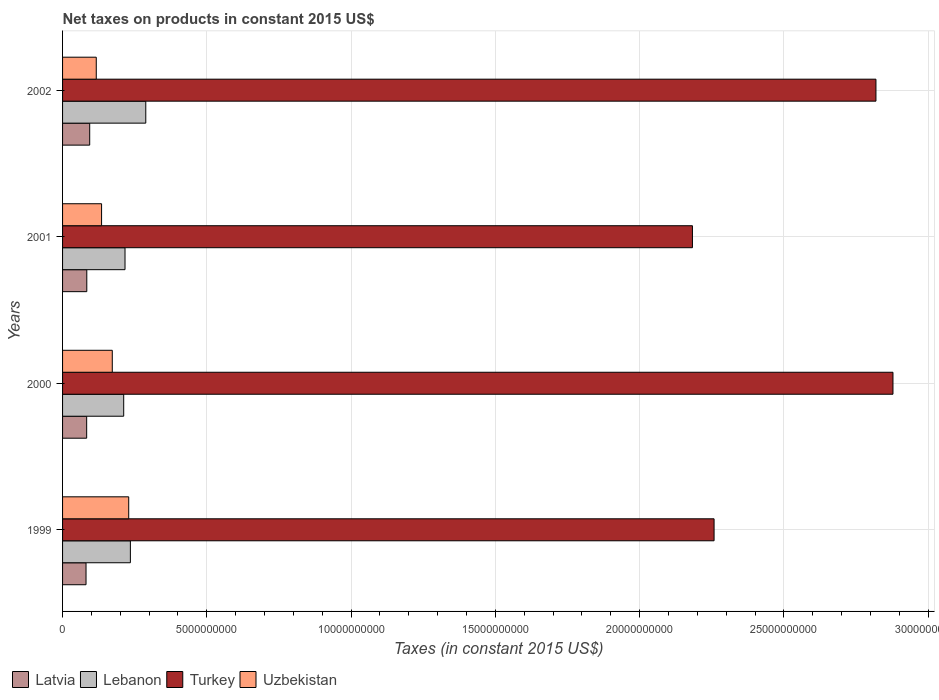How many different coloured bars are there?
Offer a very short reply. 4. How many groups of bars are there?
Offer a very short reply. 4. How many bars are there on the 2nd tick from the top?
Keep it short and to the point. 4. In how many cases, is the number of bars for a given year not equal to the number of legend labels?
Ensure brevity in your answer.  0. What is the net taxes on products in Latvia in 2000?
Provide a succinct answer. 8.36e+08. Across all years, what is the maximum net taxes on products in Lebanon?
Your answer should be compact. 2.88e+09. Across all years, what is the minimum net taxes on products in Turkey?
Your response must be concise. 2.18e+1. In which year was the net taxes on products in Uzbekistan maximum?
Ensure brevity in your answer.  1999. What is the total net taxes on products in Lebanon in the graph?
Your answer should be very brief. 9.52e+09. What is the difference between the net taxes on products in Turkey in 2000 and that in 2001?
Make the answer very short. 6.95e+09. What is the difference between the net taxes on products in Latvia in 2000 and the net taxes on products in Turkey in 1999?
Your answer should be compact. -2.17e+1. What is the average net taxes on products in Turkey per year?
Give a very brief answer. 2.53e+1. In the year 1999, what is the difference between the net taxes on products in Uzbekistan and net taxes on products in Turkey?
Keep it short and to the point. -2.03e+1. What is the ratio of the net taxes on products in Latvia in 1999 to that in 2002?
Keep it short and to the point. 0.86. Is the net taxes on products in Lebanon in 1999 less than that in 2001?
Keep it short and to the point. No. What is the difference between the highest and the second highest net taxes on products in Uzbekistan?
Provide a short and direct response. 5.70e+08. What is the difference between the highest and the lowest net taxes on products in Latvia?
Give a very brief answer. 1.27e+08. In how many years, is the net taxes on products in Uzbekistan greater than the average net taxes on products in Uzbekistan taken over all years?
Ensure brevity in your answer.  2. Is it the case that in every year, the sum of the net taxes on products in Uzbekistan and net taxes on products in Latvia is greater than the sum of net taxes on products in Lebanon and net taxes on products in Turkey?
Offer a terse response. No. What does the 4th bar from the top in 1999 represents?
Provide a short and direct response. Latvia. What does the 1st bar from the bottom in 2001 represents?
Provide a short and direct response. Latvia. Is it the case that in every year, the sum of the net taxes on products in Uzbekistan and net taxes on products in Latvia is greater than the net taxes on products in Turkey?
Provide a succinct answer. No. How many bars are there?
Provide a succinct answer. 16. Are all the bars in the graph horizontal?
Keep it short and to the point. Yes. How many years are there in the graph?
Offer a very short reply. 4. Are the values on the major ticks of X-axis written in scientific E-notation?
Your answer should be very brief. No. Does the graph contain grids?
Offer a very short reply. Yes. How are the legend labels stacked?
Ensure brevity in your answer.  Horizontal. What is the title of the graph?
Your answer should be compact. Net taxes on products in constant 2015 US$. Does "Iceland" appear as one of the legend labels in the graph?
Your answer should be very brief. No. What is the label or title of the X-axis?
Your answer should be very brief. Taxes (in constant 2015 US$). What is the label or title of the Y-axis?
Your answer should be very brief. Years. What is the Taxes (in constant 2015 US$) in Latvia in 1999?
Your answer should be compact. 8.13e+08. What is the Taxes (in constant 2015 US$) of Lebanon in 1999?
Make the answer very short. 2.35e+09. What is the Taxes (in constant 2015 US$) in Turkey in 1999?
Your answer should be very brief. 2.26e+1. What is the Taxes (in constant 2015 US$) in Uzbekistan in 1999?
Keep it short and to the point. 2.29e+09. What is the Taxes (in constant 2015 US$) in Latvia in 2000?
Ensure brevity in your answer.  8.36e+08. What is the Taxes (in constant 2015 US$) of Lebanon in 2000?
Provide a short and direct response. 2.12e+09. What is the Taxes (in constant 2015 US$) of Turkey in 2000?
Provide a succinct answer. 2.88e+1. What is the Taxes (in constant 2015 US$) in Uzbekistan in 2000?
Your answer should be very brief. 1.72e+09. What is the Taxes (in constant 2015 US$) of Latvia in 2001?
Keep it short and to the point. 8.40e+08. What is the Taxes (in constant 2015 US$) in Lebanon in 2001?
Offer a terse response. 2.16e+09. What is the Taxes (in constant 2015 US$) in Turkey in 2001?
Provide a succinct answer. 2.18e+1. What is the Taxes (in constant 2015 US$) in Uzbekistan in 2001?
Keep it short and to the point. 1.35e+09. What is the Taxes (in constant 2015 US$) of Latvia in 2002?
Offer a very short reply. 9.40e+08. What is the Taxes (in constant 2015 US$) in Lebanon in 2002?
Make the answer very short. 2.88e+09. What is the Taxes (in constant 2015 US$) of Turkey in 2002?
Make the answer very short. 2.82e+1. What is the Taxes (in constant 2015 US$) in Uzbekistan in 2002?
Make the answer very short. 1.17e+09. Across all years, what is the maximum Taxes (in constant 2015 US$) of Latvia?
Keep it short and to the point. 9.40e+08. Across all years, what is the maximum Taxes (in constant 2015 US$) in Lebanon?
Offer a terse response. 2.88e+09. Across all years, what is the maximum Taxes (in constant 2015 US$) in Turkey?
Provide a short and direct response. 2.88e+1. Across all years, what is the maximum Taxes (in constant 2015 US$) in Uzbekistan?
Offer a terse response. 2.29e+09. Across all years, what is the minimum Taxes (in constant 2015 US$) of Latvia?
Offer a very short reply. 8.13e+08. Across all years, what is the minimum Taxes (in constant 2015 US$) of Lebanon?
Your response must be concise. 2.12e+09. Across all years, what is the minimum Taxes (in constant 2015 US$) of Turkey?
Your answer should be compact. 2.18e+1. Across all years, what is the minimum Taxes (in constant 2015 US$) in Uzbekistan?
Your answer should be compact. 1.17e+09. What is the total Taxes (in constant 2015 US$) in Latvia in the graph?
Make the answer very short. 3.43e+09. What is the total Taxes (in constant 2015 US$) of Lebanon in the graph?
Your response must be concise. 9.52e+09. What is the total Taxes (in constant 2015 US$) of Turkey in the graph?
Your response must be concise. 1.01e+11. What is the total Taxes (in constant 2015 US$) in Uzbekistan in the graph?
Your answer should be very brief. 6.54e+09. What is the difference between the Taxes (in constant 2015 US$) of Latvia in 1999 and that in 2000?
Provide a short and direct response. -2.22e+07. What is the difference between the Taxes (in constant 2015 US$) in Lebanon in 1999 and that in 2000?
Keep it short and to the point. 2.32e+08. What is the difference between the Taxes (in constant 2015 US$) in Turkey in 1999 and that in 2000?
Your response must be concise. -6.20e+09. What is the difference between the Taxes (in constant 2015 US$) in Uzbekistan in 1999 and that in 2000?
Keep it short and to the point. 5.70e+08. What is the difference between the Taxes (in constant 2015 US$) in Latvia in 1999 and that in 2001?
Provide a short and direct response. -2.66e+07. What is the difference between the Taxes (in constant 2015 US$) of Lebanon in 1999 and that in 2001?
Give a very brief answer. 1.86e+08. What is the difference between the Taxes (in constant 2015 US$) in Turkey in 1999 and that in 2001?
Your answer should be very brief. 7.50e+08. What is the difference between the Taxes (in constant 2015 US$) in Uzbekistan in 1999 and that in 2001?
Ensure brevity in your answer.  9.41e+08. What is the difference between the Taxes (in constant 2015 US$) of Latvia in 1999 and that in 2002?
Your answer should be compact. -1.27e+08. What is the difference between the Taxes (in constant 2015 US$) of Lebanon in 1999 and that in 2002?
Provide a short and direct response. -5.34e+08. What is the difference between the Taxes (in constant 2015 US$) in Turkey in 1999 and that in 2002?
Your response must be concise. -5.61e+09. What is the difference between the Taxes (in constant 2015 US$) of Uzbekistan in 1999 and that in 2002?
Ensure brevity in your answer.  1.13e+09. What is the difference between the Taxes (in constant 2015 US$) in Latvia in 2000 and that in 2001?
Offer a terse response. -4.34e+06. What is the difference between the Taxes (in constant 2015 US$) in Lebanon in 2000 and that in 2001?
Keep it short and to the point. -4.58e+07. What is the difference between the Taxes (in constant 2015 US$) in Turkey in 2000 and that in 2001?
Provide a short and direct response. 6.95e+09. What is the difference between the Taxes (in constant 2015 US$) in Uzbekistan in 2000 and that in 2001?
Keep it short and to the point. 3.71e+08. What is the difference between the Taxes (in constant 2015 US$) in Latvia in 2000 and that in 2002?
Your answer should be very brief. -1.05e+08. What is the difference between the Taxes (in constant 2015 US$) in Lebanon in 2000 and that in 2002?
Provide a short and direct response. -7.66e+08. What is the difference between the Taxes (in constant 2015 US$) in Turkey in 2000 and that in 2002?
Your answer should be very brief. 5.90e+08. What is the difference between the Taxes (in constant 2015 US$) of Uzbekistan in 2000 and that in 2002?
Make the answer very short. 5.55e+08. What is the difference between the Taxes (in constant 2015 US$) of Latvia in 2001 and that in 2002?
Provide a short and direct response. -1.00e+08. What is the difference between the Taxes (in constant 2015 US$) of Lebanon in 2001 and that in 2002?
Offer a terse response. -7.20e+08. What is the difference between the Taxes (in constant 2015 US$) of Turkey in 2001 and that in 2002?
Your answer should be very brief. -6.36e+09. What is the difference between the Taxes (in constant 2015 US$) of Uzbekistan in 2001 and that in 2002?
Offer a terse response. 1.84e+08. What is the difference between the Taxes (in constant 2015 US$) of Latvia in 1999 and the Taxes (in constant 2015 US$) of Lebanon in 2000?
Give a very brief answer. -1.31e+09. What is the difference between the Taxes (in constant 2015 US$) in Latvia in 1999 and the Taxes (in constant 2015 US$) in Turkey in 2000?
Provide a succinct answer. -2.80e+1. What is the difference between the Taxes (in constant 2015 US$) of Latvia in 1999 and the Taxes (in constant 2015 US$) of Uzbekistan in 2000?
Your response must be concise. -9.10e+08. What is the difference between the Taxes (in constant 2015 US$) of Lebanon in 1999 and the Taxes (in constant 2015 US$) of Turkey in 2000?
Give a very brief answer. -2.64e+1. What is the difference between the Taxes (in constant 2015 US$) in Lebanon in 1999 and the Taxes (in constant 2015 US$) in Uzbekistan in 2000?
Your response must be concise. 6.27e+08. What is the difference between the Taxes (in constant 2015 US$) of Turkey in 1999 and the Taxes (in constant 2015 US$) of Uzbekistan in 2000?
Provide a succinct answer. 2.09e+1. What is the difference between the Taxes (in constant 2015 US$) in Latvia in 1999 and the Taxes (in constant 2015 US$) in Lebanon in 2001?
Your response must be concise. -1.35e+09. What is the difference between the Taxes (in constant 2015 US$) of Latvia in 1999 and the Taxes (in constant 2015 US$) of Turkey in 2001?
Your response must be concise. -2.10e+1. What is the difference between the Taxes (in constant 2015 US$) in Latvia in 1999 and the Taxes (in constant 2015 US$) in Uzbekistan in 2001?
Keep it short and to the point. -5.39e+08. What is the difference between the Taxes (in constant 2015 US$) of Lebanon in 1999 and the Taxes (in constant 2015 US$) of Turkey in 2001?
Your response must be concise. -1.95e+1. What is the difference between the Taxes (in constant 2015 US$) of Lebanon in 1999 and the Taxes (in constant 2015 US$) of Uzbekistan in 2001?
Offer a very short reply. 9.98e+08. What is the difference between the Taxes (in constant 2015 US$) of Turkey in 1999 and the Taxes (in constant 2015 US$) of Uzbekistan in 2001?
Provide a succinct answer. 2.12e+1. What is the difference between the Taxes (in constant 2015 US$) in Latvia in 1999 and the Taxes (in constant 2015 US$) in Lebanon in 2002?
Offer a very short reply. -2.07e+09. What is the difference between the Taxes (in constant 2015 US$) in Latvia in 1999 and the Taxes (in constant 2015 US$) in Turkey in 2002?
Provide a short and direct response. -2.74e+1. What is the difference between the Taxes (in constant 2015 US$) of Latvia in 1999 and the Taxes (in constant 2015 US$) of Uzbekistan in 2002?
Provide a succinct answer. -3.55e+08. What is the difference between the Taxes (in constant 2015 US$) of Lebanon in 1999 and the Taxes (in constant 2015 US$) of Turkey in 2002?
Offer a very short reply. -2.58e+1. What is the difference between the Taxes (in constant 2015 US$) in Lebanon in 1999 and the Taxes (in constant 2015 US$) in Uzbekistan in 2002?
Provide a short and direct response. 1.18e+09. What is the difference between the Taxes (in constant 2015 US$) in Turkey in 1999 and the Taxes (in constant 2015 US$) in Uzbekistan in 2002?
Your answer should be compact. 2.14e+1. What is the difference between the Taxes (in constant 2015 US$) in Latvia in 2000 and the Taxes (in constant 2015 US$) in Lebanon in 2001?
Offer a terse response. -1.33e+09. What is the difference between the Taxes (in constant 2015 US$) in Latvia in 2000 and the Taxes (in constant 2015 US$) in Turkey in 2001?
Your answer should be very brief. -2.10e+1. What is the difference between the Taxes (in constant 2015 US$) of Latvia in 2000 and the Taxes (in constant 2015 US$) of Uzbekistan in 2001?
Keep it short and to the point. -5.17e+08. What is the difference between the Taxes (in constant 2015 US$) in Lebanon in 2000 and the Taxes (in constant 2015 US$) in Turkey in 2001?
Your answer should be compact. -1.97e+1. What is the difference between the Taxes (in constant 2015 US$) in Lebanon in 2000 and the Taxes (in constant 2015 US$) in Uzbekistan in 2001?
Offer a very short reply. 7.67e+08. What is the difference between the Taxes (in constant 2015 US$) of Turkey in 2000 and the Taxes (in constant 2015 US$) of Uzbekistan in 2001?
Your answer should be very brief. 2.74e+1. What is the difference between the Taxes (in constant 2015 US$) of Latvia in 2000 and the Taxes (in constant 2015 US$) of Lebanon in 2002?
Your answer should be very brief. -2.05e+09. What is the difference between the Taxes (in constant 2015 US$) in Latvia in 2000 and the Taxes (in constant 2015 US$) in Turkey in 2002?
Provide a succinct answer. -2.74e+1. What is the difference between the Taxes (in constant 2015 US$) in Latvia in 2000 and the Taxes (in constant 2015 US$) in Uzbekistan in 2002?
Ensure brevity in your answer.  -3.32e+08. What is the difference between the Taxes (in constant 2015 US$) of Lebanon in 2000 and the Taxes (in constant 2015 US$) of Turkey in 2002?
Offer a terse response. -2.61e+1. What is the difference between the Taxes (in constant 2015 US$) of Lebanon in 2000 and the Taxes (in constant 2015 US$) of Uzbekistan in 2002?
Provide a succinct answer. 9.51e+08. What is the difference between the Taxes (in constant 2015 US$) of Turkey in 2000 and the Taxes (in constant 2015 US$) of Uzbekistan in 2002?
Make the answer very short. 2.76e+1. What is the difference between the Taxes (in constant 2015 US$) in Latvia in 2001 and the Taxes (in constant 2015 US$) in Lebanon in 2002?
Provide a short and direct response. -2.04e+09. What is the difference between the Taxes (in constant 2015 US$) in Latvia in 2001 and the Taxes (in constant 2015 US$) in Turkey in 2002?
Make the answer very short. -2.74e+1. What is the difference between the Taxes (in constant 2015 US$) of Latvia in 2001 and the Taxes (in constant 2015 US$) of Uzbekistan in 2002?
Make the answer very short. -3.28e+08. What is the difference between the Taxes (in constant 2015 US$) of Lebanon in 2001 and the Taxes (in constant 2015 US$) of Turkey in 2002?
Offer a terse response. -2.60e+1. What is the difference between the Taxes (in constant 2015 US$) of Lebanon in 2001 and the Taxes (in constant 2015 US$) of Uzbekistan in 2002?
Provide a succinct answer. 9.97e+08. What is the difference between the Taxes (in constant 2015 US$) of Turkey in 2001 and the Taxes (in constant 2015 US$) of Uzbekistan in 2002?
Your answer should be very brief. 2.07e+1. What is the average Taxes (in constant 2015 US$) of Latvia per year?
Ensure brevity in your answer.  8.57e+08. What is the average Taxes (in constant 2015 US$) in Lebanon per year?
Make the answer very short. 2.38e+09. What is the average Taxes (in constant 2015 US$) of Turkey per year?
Keep it short and to the point. 2.53e+1. What is the average Taxes (in constant 2015 US$) of Uzbekistan per year?
Your answer should be compact. 1.63e+09. In the year 1999, what is the difference between the Taxes (in constant 2015 US$) in Latvia and Taxes (in constant 2015 US$) in Lebanon?
Your answer should be very brief. -1.54e+09. In the year 1999, what is the difference between the Taxes (in constant 2015 US$) of Latvia and Taxes (in constant 2015 US$) of Turkey?
Make the answer very short. -2.18e+1. In the year 1999, what is the difference between the Taxes (in constant 2015 US$) in Latvia and Taxes (in constant 2015 US$) in Uzbekistan?
Your response must be concise. -1.48e+09. In the year 1999, what is the difference between the Taxes (in constant 2015 US$) of Lebanon and Taxes (in constant 2015 US$) of Turkey?
Keep it short and to the point. -2.02e+1. In the year 1999, what is the difference between the Taxes (in constant 2015 US$) of Lebanon and Taxes (in constant 2015 US$) of Uzbekistan?
Make the answer very short. 5.74e+07. In the year 1999, what is the difference between the Taxes (in constant 2015 US$) of Turkey and Taxes (in constant 2015 US$) of Uzbekistan?
Provide a succinct answer. 2.03e+1. In the year 2000, what is the difference between the Taxes (in constant 2015 US$) of Latvia and Taxes (in constant 2015 US$) of Lebanon?
Ensure brevity in your answer.  -1.28e+09. In the year 2000, what is the difference between the Taxes (in constant 2015 US$) of Latvia and Taxes (in constant 2015 US$) of Turkey?
Offer a terse response. -2.79e+1. In the year 2000, what is the difference between the Taxes (in constant 2015 US$) of Latvia and Taxes (in constant 2015 US$) of Uzbekistan?
Make the answer very short. -8.88e+08. In the year 2000, what is the difference between the Taxes (in constant 2015 US$) in Lebanon and Taxes (in constant 2015 US$) in Turkey?
Your response must be concise. -2.67e+1. In the year 2000, what is the difference between the Taxes (in constant 2015 US$) in Lebanon and Taxes (in constant 2015 US$) in Uzbekistan?
Your answer should be very brief. 3.96e+08. In the year 2000, what is the difference between the Taxes (in constant 2015 US$) in Turkey and Taxes (in constant 2015 US$) in Uzbekistan?
Offer a very short reply. 2.71e+1. In the year 2001, what is the difference between the Taxes (in constant 2015 US$) in Latvia and Taxes (in constant 2015 US$) in Lebanon?
Your answer should be compact. -1.32e+09. In the year 2001, what is the difference between the Taxes (in constant 2015 US$) of Latvia and Taxes (in constant 2015 US$) of Turkey?
Your answer should be very brief. -2.10e+1. In the year 2001, what is the difference between the Taxes (in constant 2015 US$) in Latvia and Taxes (in constant 2015 US$) in Uzbekistan?
Offer a terse response. -5.12e+08. In the year 2001, what is the difference between the Taxes (in constant 2015 US$) in Lebanon and Taxes (in constant 2015 US$) in Turkey?
Provide a short and direct response. -1.97e+1. In the year 2001, what is the difference between the Taxes (in constant 2015 US$) in Lebanon and Taxes (in constant 2015 US$) in Uzbekistan?
Keep it short and to the point. 8.12e+08. In the year 2001, what is the difference between the Taxes (in constant 2015 US$) in Turkey and Taxes (in constant 2015 US$) in Uzbekistan?
Keep it short and to the point. 2.05e+1. In the year 2002, what is the difference between the Taxes (in constant 2015 US$) of Latvia and Taxes (in constant 2015 US$) of Lebanon?
Provide a short and direct response. -1.94e+09. In the year 2002, what is the difference between the Taxes (in constant 2015 US$) in Latvia and Taxes (in constant 2015 US$) in Turkey?
Your response must be concise. -2.73e+1. In the year 2002, what is the difference between the Taxes (in constant 2015 US$) in Latvia and Taxes (in constant 2015 US$) in Uzbekistan?
Ensure brevity in your answer.  -2.28e+08. In the year 2002, what is the difference between the Taxes (in constant 2015 US$) of Lebanon and Taxes (in constant 2015 US$) of Turkey?
Your response must be concise. -2.53e+1. In the year 2002, what is the difference between the Taxes (in constant 2015 US$) of Lebanon and Taxes (in constant 2015 US$) of Uzbekistan?
Give a very brief answer. 1.72e+09. In the year 2002, what is the difference between the Taxes (in constant 2015 US$) in Turkey and Taxes (in constant 2015 US$) in Uzbekistan?
Provide a succinct answer. 2.70e+1. What is the ratio of the Taxes (in constant 2015 US$) of Latvia in 1999 to that in 2000?
Provide a short and direct response. 0.97. What is the ratio of the Taxes (in constant 2015 US$) in Lebanon in 1999 to that in 2000?
Provide a short and direct response. 1.11. What is the ratio of the Taxes (in constant 2015 US$) of Turkey in 1999 to that in 2000?
Ensure brevity in your answer.  0.78. What is the ratio of the Taxes (in constant 2015 US$) in Uzbekistan in 1999 to that in 2000?
Give a very brief answer. 1.33. What is the ratio of the Taxes (in constant 2015 US$) of Latvia in 1999 to that in 2001?
Your answer should be very brief. 0.97. What is the ratio of the Taxes (in constant 2015 US$) of Lebanon in 1999 to that in 2001?
Keep it short and to the point. 1.09. What is the ratio of the Taxes (in constant 2015 US$) in Turkey in 1999 to that in 2001?
Make the answer very short. 1.03. What is the ratio of the Taxes (in constant 2015 US$) in Uzbekistan in 1999 to that in 2001?
Provide a succinct answer. 1.7. What is the ratio of the Taxes (in constant 2015 US$) in Latvia in 1999 to that in 2002?
Your answer should be very brief. 0.86. What is the ratio of the Taxes (in constant 2015 US$) in Lebanon in 1999 to that in 2002?
Provide a short and direct response. 0.81. What is the ratio of the Taxes (in constant 2015 US$) of Turkey in 1999 to that in 2002?
Your response must be concise. 0.8. What is the ratio of the Taxes (in constant 2015 US$) of Uzbekistan in 1999 to that in 2002?
Your answer should be compact. 1.96. What is the ratio of the Taxes (in constant 2015 US$) in Latvia in 2000 to that in 2001?
Ensure brevity in your answer.  0.99. What is the ratio of the Taxes (in constant 2015 US$) of Lebanon in 2000 to that in 2001?
Offer a terse response. 0.98. What is the ratio of the Taxes (in constant 2015 US$) of Turkey in 2000 to that in 2001?
Make the answer very short. 1.32. What is the ratio of the Taxes (in constant 2015 US$) of Uzbekistan in 2000 to that in 2001?
Your response must be concise. 1.27. What is the ratio of the Taxes (in constant 2015 US$) of Latvia in 2000 to that in 2002?
Your answer should be very brief. 0.89. What is the ratio of the Taxes (in constant 2015 US$) in Lebanon in 2000 to that in 2002?
Provide a short and direct response. 0.73. What is the ratio of the Taxes (in constant 2015 US$) of Turkey in 2000 to that in 2002?
Offer a very short reply. 1.02. What is the ratio of the Taxes (in constant 2015 US$) of Uzbekistan in 2000 to that in 2002?
Give a very brief answer. 1.48. What is the ratio of the Taxes (in constant 2015 US$) of Latvia in 2001 to that in 2002?
Your answer should be very brief. 0.89. What is the ratio of the Taxes (in constant 2015 US$) of Lebanon in 2001 to that in 2002?
Your answer should be compact. 0.75. What is the ratio of the Taxes (in constant 2015 US$) in Turkey in 2001 to that in 2002?
Provide a succinct answer. 0.77. What is the ratio of the Taxes (in constant 2015 US$) in Uzbekistan in 2001 to that in 2002?
Make the answer very short. 1.16. What is the difference between the highest and the second highest Taxes (in constant 2015 US$) in Latvia?
Your answer should be compact. 1.00e+08. What is the difference between the highest and the second highest Taxes (in constant 2015 US$) of Lebanon?
Your answer should be compact. 5.34e+08. What is the difference between the highest and the second highest Taxes (in constant 2015 US$) in Turkey?
Your response must be concise. 5.90e+08. What is the difference between the highest and the second highest Taxes (in constant 2015 US$) in Uzbekistan?
Keep it short and to the point. 5.70e+08. What is the difference between the highest and the lowest Taxes (in constant 2015 US$) in Latvia?
Ensure brevity in your answer.  1.27e+08. What is the difference between the highest and the lowest Taxes (in constant 2015 US$) in Lebanon?
Your answer should be compact. 7.66e+08. What is the difference between the highest and the lowest Taxes (in constant 2015 US$) in Turkey?
Your response must be concise. 6.95e+09. What is the difference between the highest and the lowest Taxes (in constant 2015 US$) of Uzbekistan?
Offer a very short reply. 1.13e+09. 